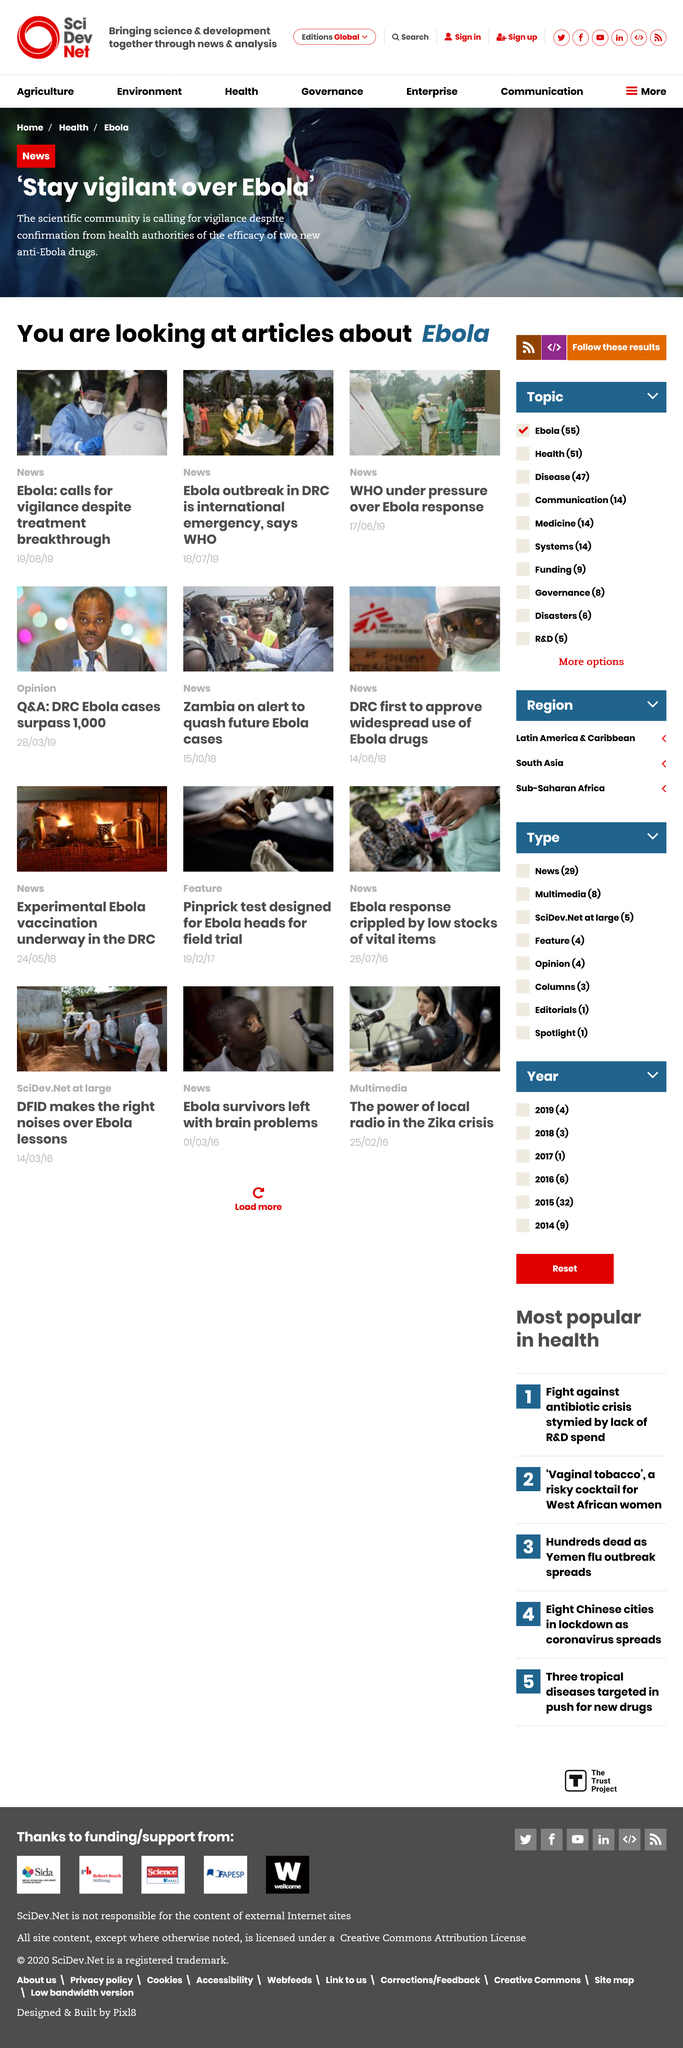Outline some significant characteristics in this image. The articles we are examining pertain to Ebola. The scientific community is calling for vigilance despite the known efficiency of two new drugs, as they are concerned about potential risks. The WHO feature was published on 17th June 2019, and it was under pressure at the time of its publication. 